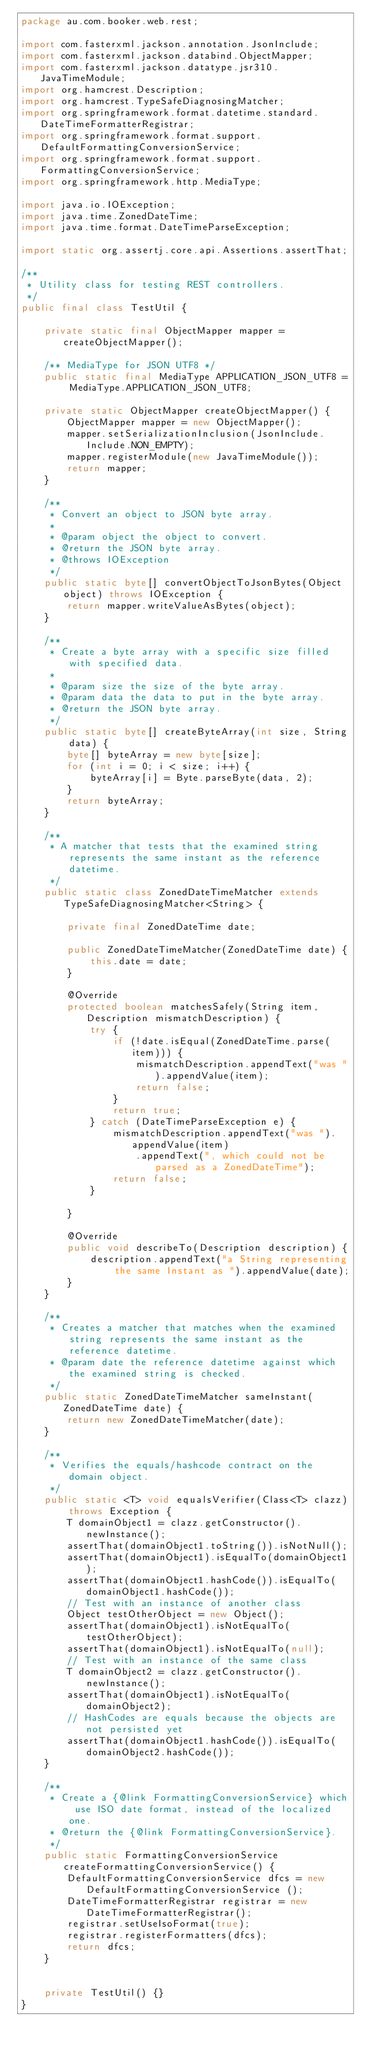Convert code to text. <code><loc_0><loc_0><loc_500><loc_500><_Java_>package au.com.booker.web.rest;

import com.fasterxml.jackson.annotation.JsonInclude;
import com.fasterxml.jackson.databind.ObjectMapper;
import com.fasterxml.jackson.datatype.jsr310.JavaTimeModule;
import org.hamcrest.Description;
import org.hamcrest.TypeSafeDiagnosingMatcher;
import org.springframework.format.datetime.standard.DateTimeFormatterRegistrar;
import org.springframework.format.support.DefaultFormattingConversionService;
import org.springframework.format.support.FormattingConversionService;
import org.springframework.http.MediaType;

import java.io.IOException;
import java.time.ZonedDateTime;
import java.time.format.DateTimeParseException;

import static org.assertj.core.api.Assertions.assertThat;

/**
 * Utility class for testing REST controllers.
 */
public final class TestUtil {

    private static final ObjectMapper mapper = createObjectMapper();

    /** MediaType for JSON UTF8 */
    public static final MediaType APPLICATION_JSON_UTF8 = MediaType.APPLICATION_JSON_UTF8;

    private static ObjectMapper createObjectMapper() {
        ObjectMapper mapper = new ObjectMapper();
        mapper.setSerializationInclusion(JsonInclude.Include.NON_EMPTY);
        mapper.registerModule(new JavaTimeModule());
        return mapper;
    }

    /**
     * Convert an object to JSON byte array.
     *
     * @param object the object to convert.
     * @return the JSON byte array.
     * @throws IOException
     */
    public static byte[] convertObjectToJsonBytes(Object object) throws IOException {
        return mapper.writeValueAsBytes(object);
    }

    /**
     * Create a byte array with a specific size filled with specified data.
     *
     * @param size the size of the byte array.
     * @param data the data to put in the byte array.
     * @return the JSON byte array.
     */
    public static byte[] createByteArray(int size, String data) {
        byte[] byteArray = new byte[size];
        for (int i = 0; i < size; i++) {
            byteArray[i] = Byte.parseByte(data, 2);
        }
        return byteArray;
    }

    /**
     * A matcher that tests that the examined string represents the same instant as the reference datetime.
     */
    public static class ZonedDateTimeMatcher extends TypeSafeDiagnosingMatcher<String> {

        private final ZonedDateTime date;

        public ZonedDateTimeMatcher(ZonedDateTime date) {
            this.date = date;
        }

        @Override
        protected boolean matchesSafely(String item, Description mismatchDescription) {
            try {
                if (!date.isEqual(ZonedDateTime.parse(item))) {
                    mismatchDescription.appendText("was ").appendValue(item);
                    return false;
                }
                return true;
            } catch (DateTimeParseException e) {
                mismatchDescription.appendText("was ").appendValue(item)
                    .appendText(", which could not be parsed as a ZonedDateTime");
                return false;
            }

        }

        @Override
        public void describeTo(Description description) {
            description.appendText("a String representing the same Instant as ").appendValue(date);
        }
    }

    /**
     * Creates a matcher that matches when the examined string represents the same instant as the reference datetime.
     * @param date the reference datetime against which the examined string is checked.
     */
    public static ZonedDateTimeMatcher sameInstant(ZonedDateTime date) {
        return new ZonedDateTimeMatcher(date);
    }

    /**
     * Verifies the equals/hashcode contract on the domain object.
     */
    public static <T> void equalsVerifier(Class<T> clazz) throws Exception {
        T domainObject1 = clazz.getConstructor().newInstance();
        assertThat(domainObject1.toString()).isNotNull();
        assertThat(domainObject1).isEqualTo(domainObject1);
        assertThat(domainObject1.hashCode()).isEqualTo(domainObject1.hashCode());
        // Test with an instance of another class
        Object testOtherObject = new Object();
        assertThat(domainObject1).isNotEqualTo(testOtherObject);
        assertThat(domainObject1).isNotEqualTo(null);
        // Test with an instance of the same class
        T domainObject2 = clazz.getConstructor().newInstance();
        assertThat(domainObject1).isNotEqualTo(domainObject2);
        // HashCodes are equals because the objects are not persisted yet
        assertThat(domainObject1.hashCode()).isEqualTo(domainObject2.hashCode());
    }

    /**
     * Create a {@link FormattingConversionService} which use ISO date format, instead of the localized one.
     * @return the {@link FormattingConversionService}.
     */
    public static FormattingConversionService createFormattingConversionService() {
        DefaultFormattingConversionService dfcs = new DefaultFormattingConversionService ();
        DateTimeFormatterRegistrar registrar = new DateTimeFormatterRegistrar();
        registrar.setUseIsoFormat(true);
        registrar.registerFormatters(dfcs);
        return dfcs;
    }


    private TestUtil() {}
}
</code> 